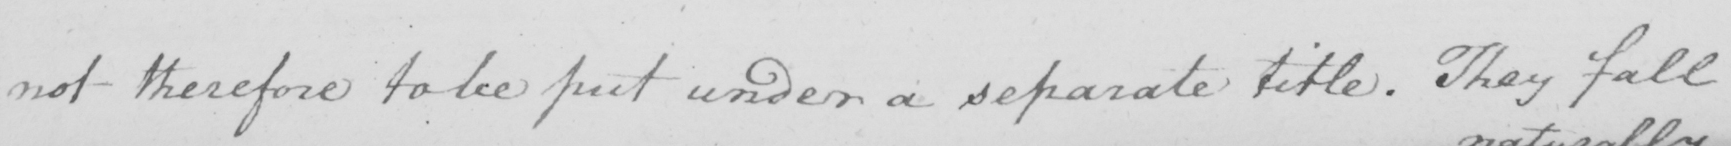What text is written in this handwritten line? not therefore to be put under a separate title . They fall 